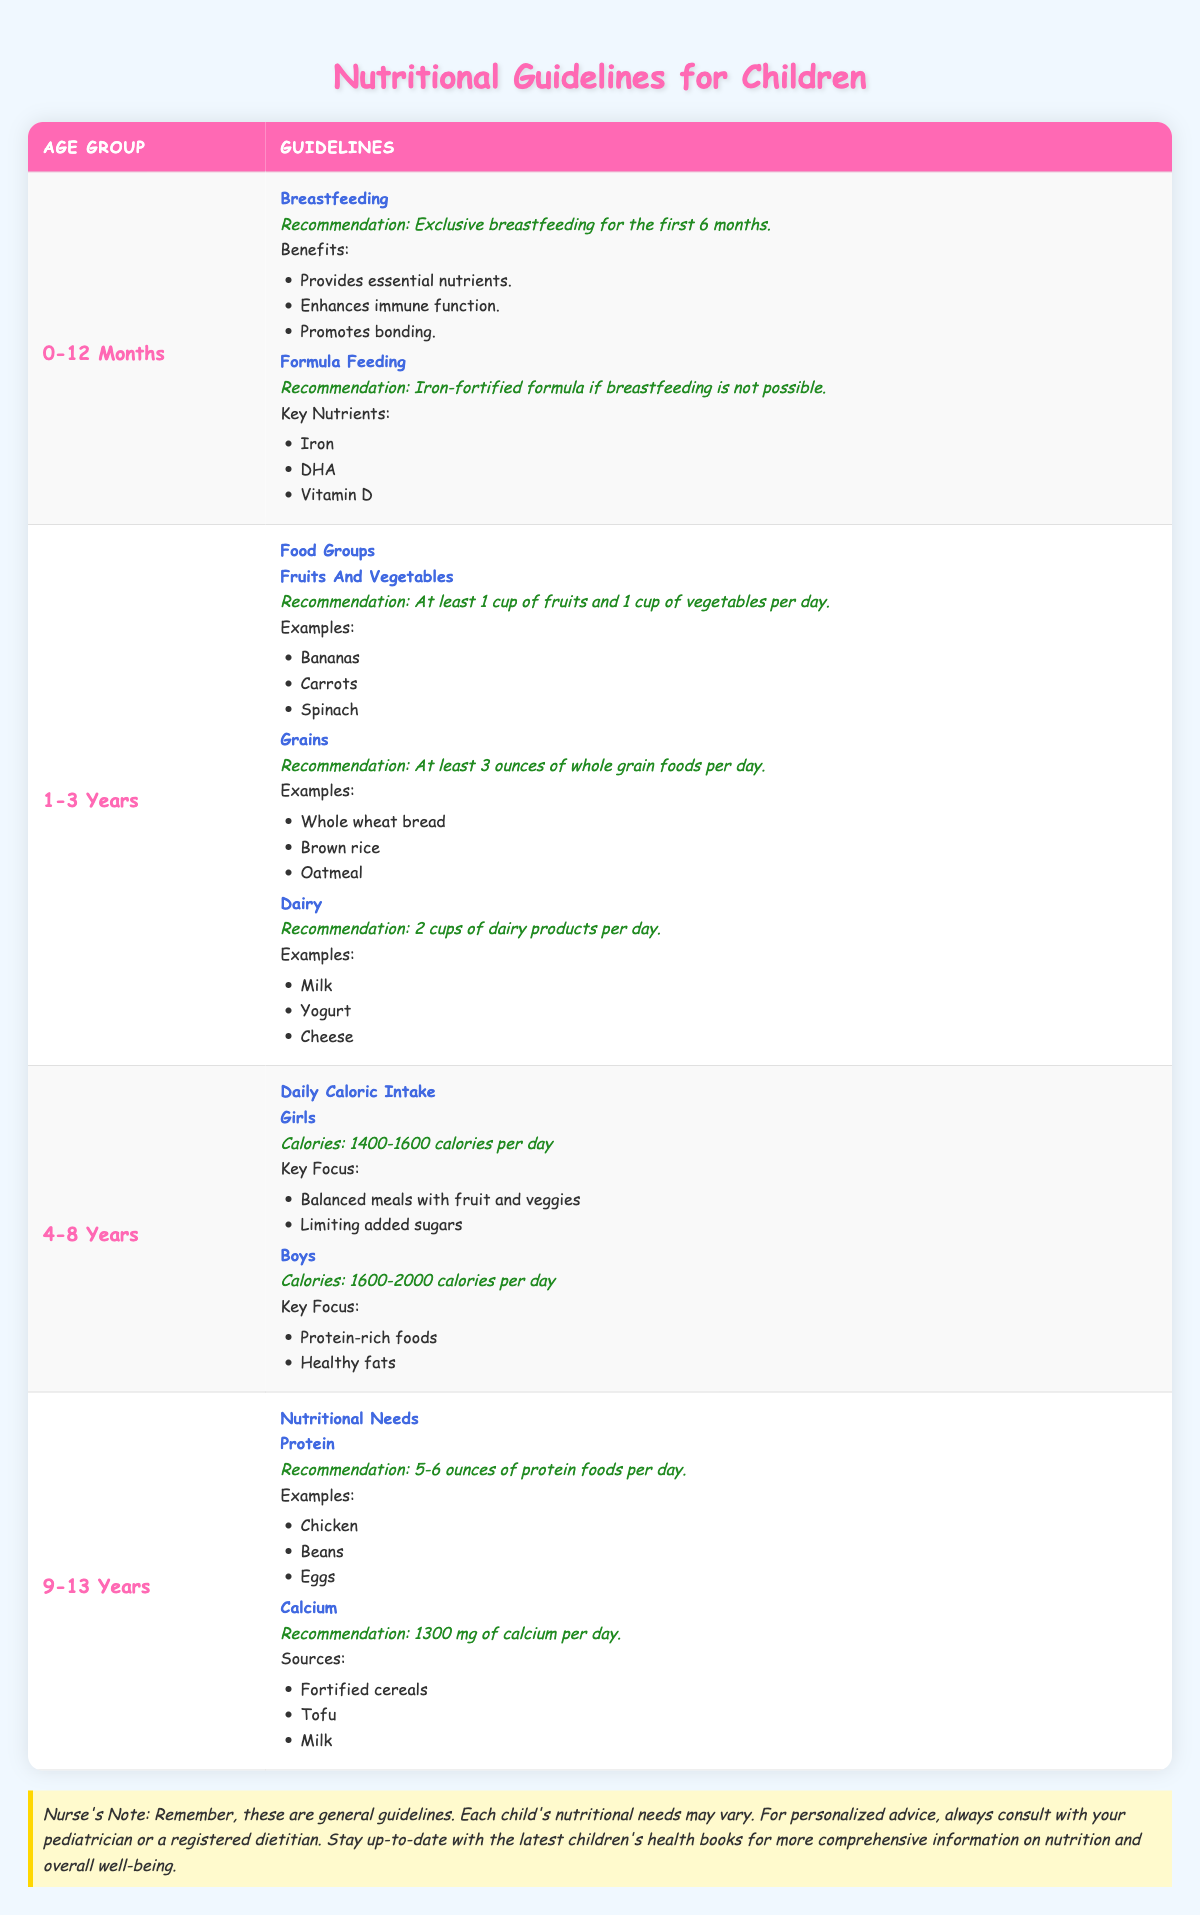What is the recommendation for breastfeeding in the 0-12 months age group? The table specifies that the recommendation for breastfeeding is exclusive breastfeeding for the first 6 months for infants aged 0-12 months.
Answer: Exclusive breastfeeding for the first 6 months How many cups of dairy products should children aged 1-3 years consume daily? According to the table, children in this age group should consume 2 cups of dairy products each day.
Answer: 2 cups What are the key nutrients in formula feeding for infants if breastfeeding is not possible? The table lists key nutrients for formula feeding as Iron, DHA, and Vitamin D.
Answer: Iron, DHA, Vitamin D True or False: Boys aged 4-8 years should consume between 1400-1600 calories per day. The table indicates that boys in this age range should consume 1600-2000 calories per day, thus this statement is false.
Answer: False What is the total amount of protein recommended for children aged 9-13 years per day? The recommendation for protein intake for children aged 9-13 years is 5-6 ounces per day. The total range is 5 to 6 ounces, averaging 5.5 ounces.
Answer: 5-6 ounces What is the recommendation for fruits and vegetables for the 1-3 years age group? The recommendation for children aged 1-3 years is to consume at least 1 cup of fruits and 1 cup of vegetables per day.
Answer: At least 1 cup of fruits and 1 cup of vegetables How many ounces of protein foods are recommended for children aged 9-13 years? The table recommends that children aged 9-13 years consume 5-6 ounces of protein foods per day.
Answer: 5-6 ounces What is the calcium recommendation for children aged 9-13 years, and can you list at least two sources? The recommendation for calcium intake for children aged 9-13 years is 1300 mg per day. The sources include fortified cereals and milk.
Answer: 1300 mg; fortified cereals, milk Are children in the 4-8 years age group advised to limit added sugars? Yes, the table states a key focus for girls in this age group is limiting added sugars, so the answer is affirmative.
Answer: Yes 